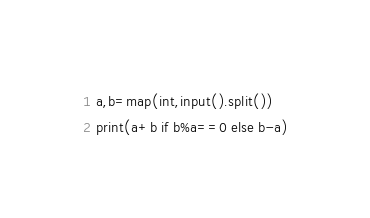<code> <loc_0><loc_0><loc_500><loc_500><_Python_>a,b=map(int,input().split())
print(a+b if b%a==0 else b-a)</code> 